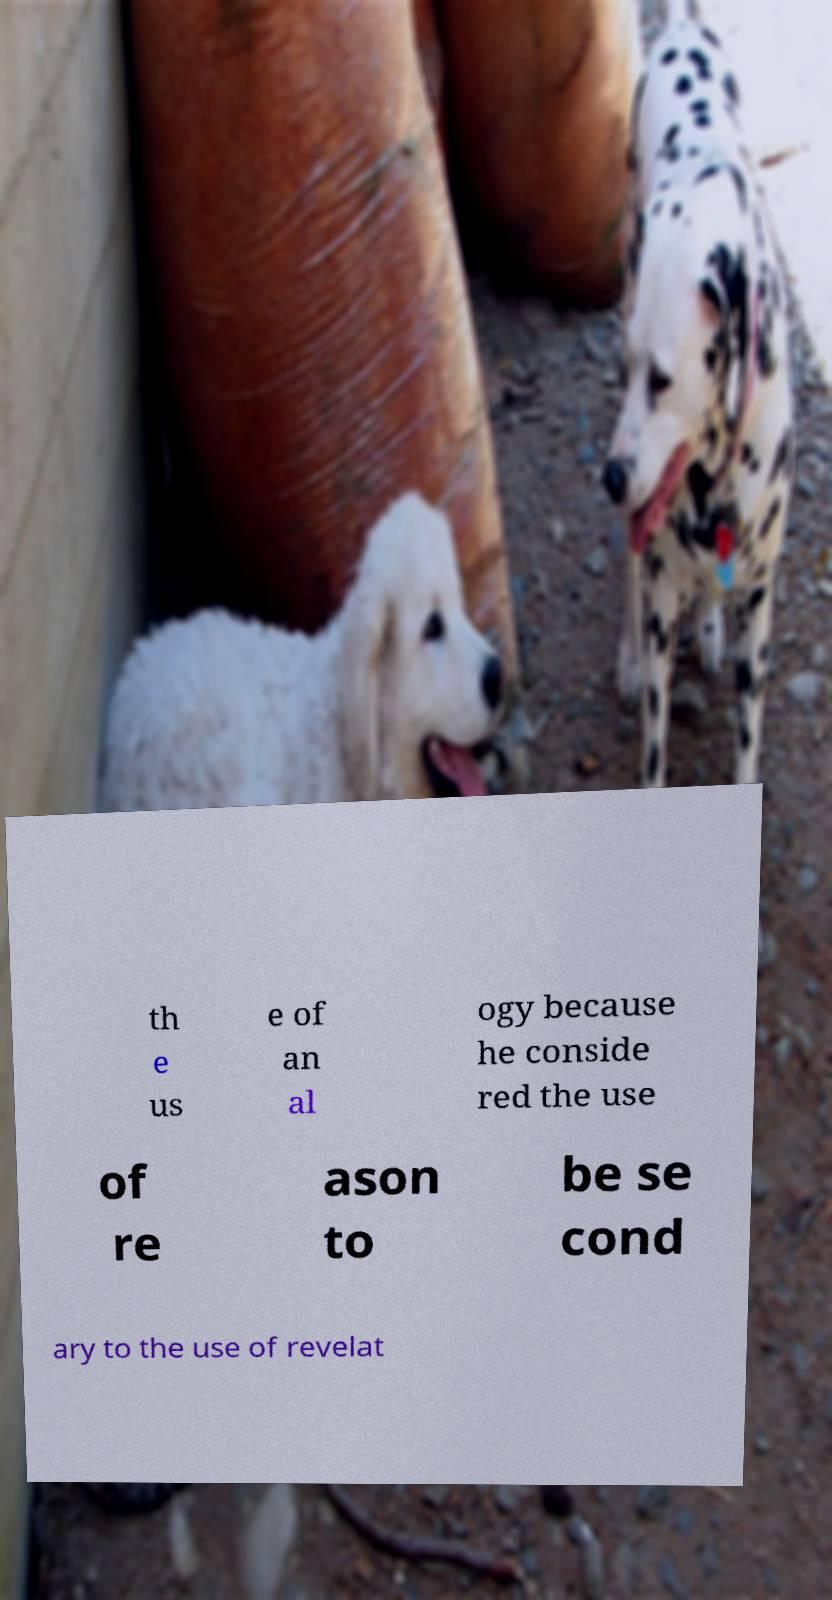Can you accurately transcribe the text from the provided image for me? th e us e of an al ogy because he conside red the use of re ason to be se cond ary to the use of revelat 